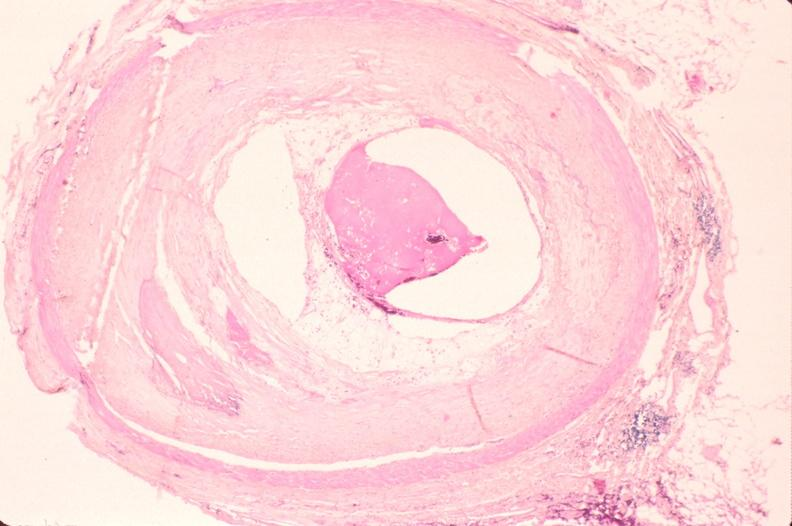how is atherosclerosis left anterior descending artery?
Answer the question using a single word or phrase. Coronary 